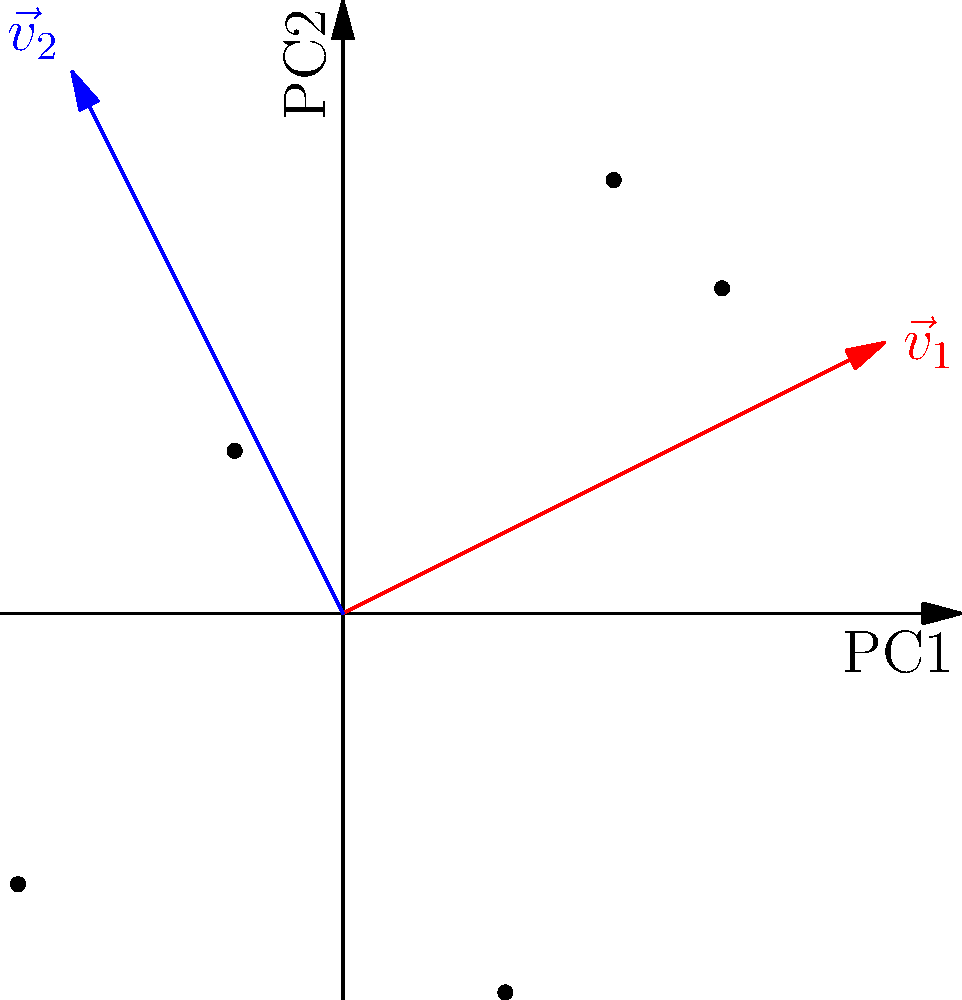Given the PCA projection of a high-dimensional dataset onto a 2D plane as shown in the figure, where the red and blue arrows represent the first and second principal components respectively, what can be inferred about the direction of maximum variance in the original dataset? To answer this question, we need to understand the principles of PCA and interpret the given visualization:

1. PCA aims to find orthogonal directions (principal components) that capture the maximum variance in the data.

2. The first principal component (PC1) always points in the direction of maximum variance in the dataset.

3. In the given figure, PC1 is represented by the red arrow ($\vec{v}_1$), which is longer and more aligned with the x-axis.

4. PC2, represented by the blue arrow ($\vec{v}_2$), is orthogonal to PC1 and captures the second highest variance.

5. The length of each arrow is proportional to the amount of variance explained by that principal component.

6. We can observe that the red arrow ($\vec{v}_1$) is longer than the blue arrow ($\vec{v}_2$), indicating that PC1 explains more variance than PC2.

7. The direction of $\vec{v}_1$ is approximately aligned with the positive x-axis and slightly tilted upwards.

Therefore, we can infer that the direction of maximum variance in the original high-dimensional dataset corresponds to the direction of $\vec{v}_1$, which is predominantly along the positive x-axis with a slight upward tilt in this 2D projection.
Answer: Along the direction of $\vec{v}_1$ (predominantly positive x-axis with slight upward tilt) 